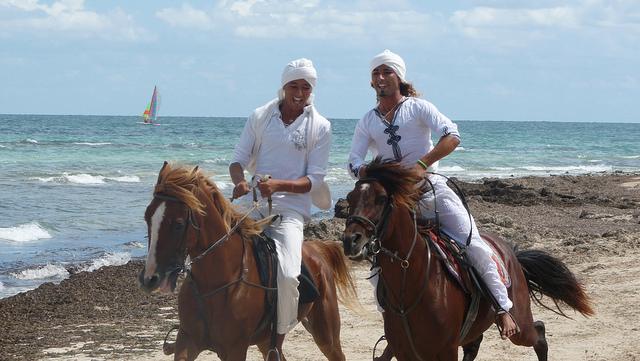Why are they so close together?
Indicate the correct response and explain using: 'Answer: answer
Rationale: rationale.'
Options: To talk, need directions, afraid alone, to fight. Answer: to talk.
Rationale: The two people are leaning toward each other and theirs mouths are partially opened. 